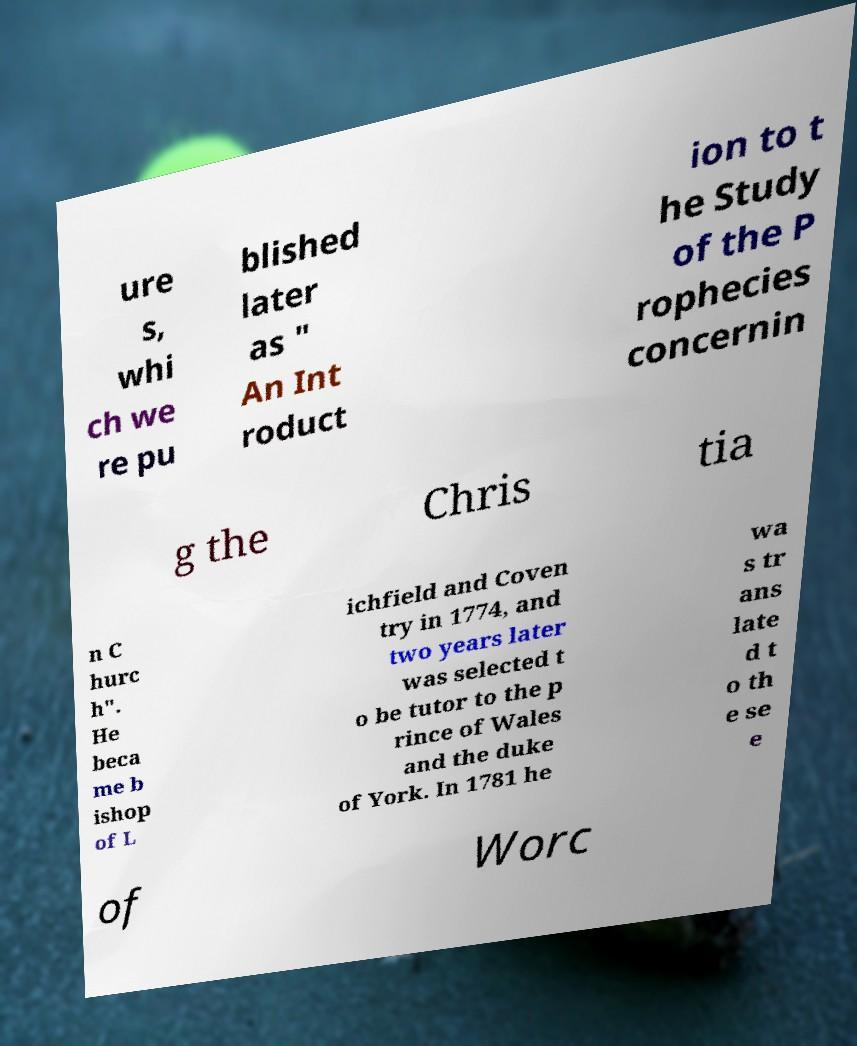Please read and relay the text visible in this image. What does it say? ure s, whi ch we re pu blished later as " An Int roduct ion to t he Study of the P rophecies concernin g the Chris tia n C hurc h". He beca me b ishop of L ichfield and Coven try in 1774, and two years later was selected t o be tutor to the p rince of Wales and the duke of York. In 1781 he wa s tr ans late d t o th e se e of Worc 